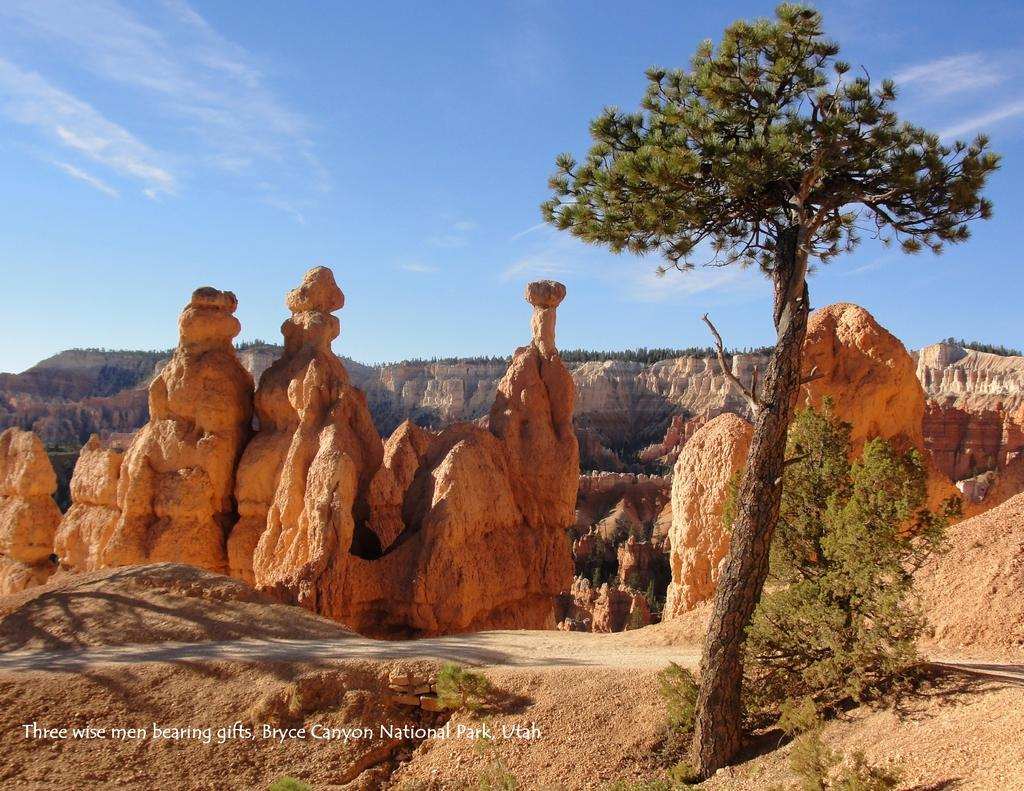What type of geological formation can be seen in the image? There are rock hills in the image. What type of vegetation is present in the image? There are trees, plants, and grass visible in the image. What part of the natural environment is visible in the image? The ground, sky, and clouds are visible in the image. Is there any text present in the image? Yes, there is some text at the bottom of the image. Can you tell me how many turkeys are grazing on the grass in the image? There are no turkeys present in the image; it features rock hills, trees, plants, grass, and text. What type of rod is being used to measure the height of the clouds in the image? There is no rod present in the image, and the height of the clouds is not being measured. 